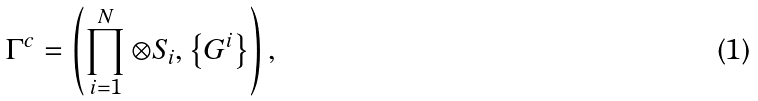<formula> <loc_0><loc_0><loc_500><loc_500>\Gamma ^ { c } = \left ( \prod _ { i = 1 } ^ { N } \otimes S _ { i } , \left \{ G ^ { i } \right \} \right ) ,</formula> 